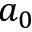Convert formula to latex. <formula><loc_0><loc_0><loc_500><loc_500>a _ { 0 }</formula> 